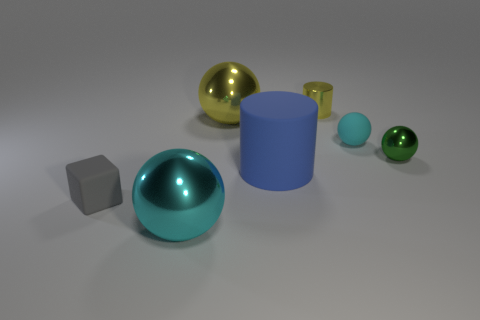Add 2 brown metal balls. How many objects exist? 9 Subtract all cylinders. How many objects are left? 5 Subtract 0 blue spheres. How many objects are left? 7 Subtract all green matte spheres. Subtract all small yellow metal cylinders. How many objects are left? 6 Add 5 green things. How many green things are left? 6 Add 1 small gray blocks. How many small gray blocks exist? 2 